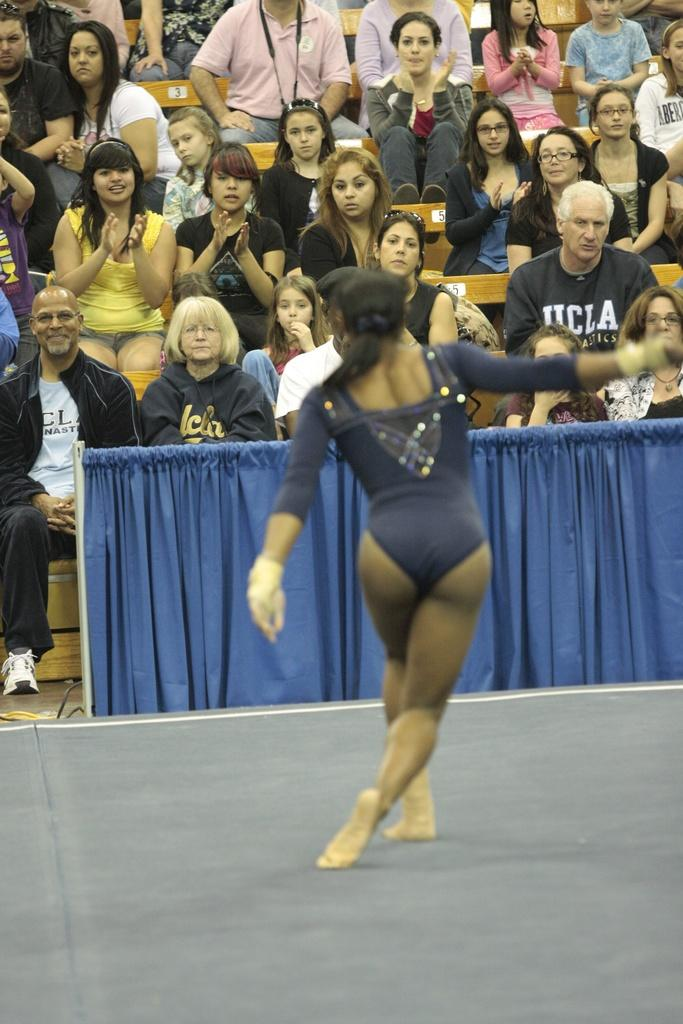Who is the main subject in the image? There is a lady in the center of the image. What can be seen in the background of the image? There is a crowd sitting in the background of the image. Is there any object or feature related to covering or concealing in the image? Yes, there is a curtain in the image. How many veins can be seen on the lady's arm in the image? There is no visible arm or veins on the lady in the image. What type of rail is present in the image? There is no rail present in the image. 